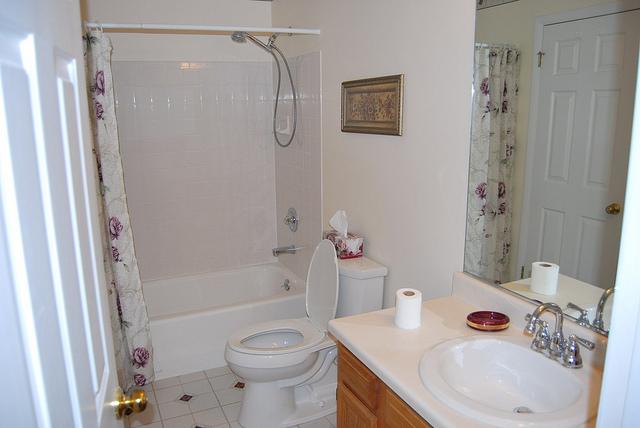What is the brown thing sitting on the counter next to the sink?
Answer briefly. Soap dish. What animal is on the curtain?
Quick response, please. None. How many towels are there?
Answer briefly. 0. Is the sink on?
Short answer required. No. How many sinks are there?
Keep it brief. 1. What is on the shower curtain?
Keep it brief. Flowers. What is the pattern of the shower curtain?
Concise answer only. Floral. 